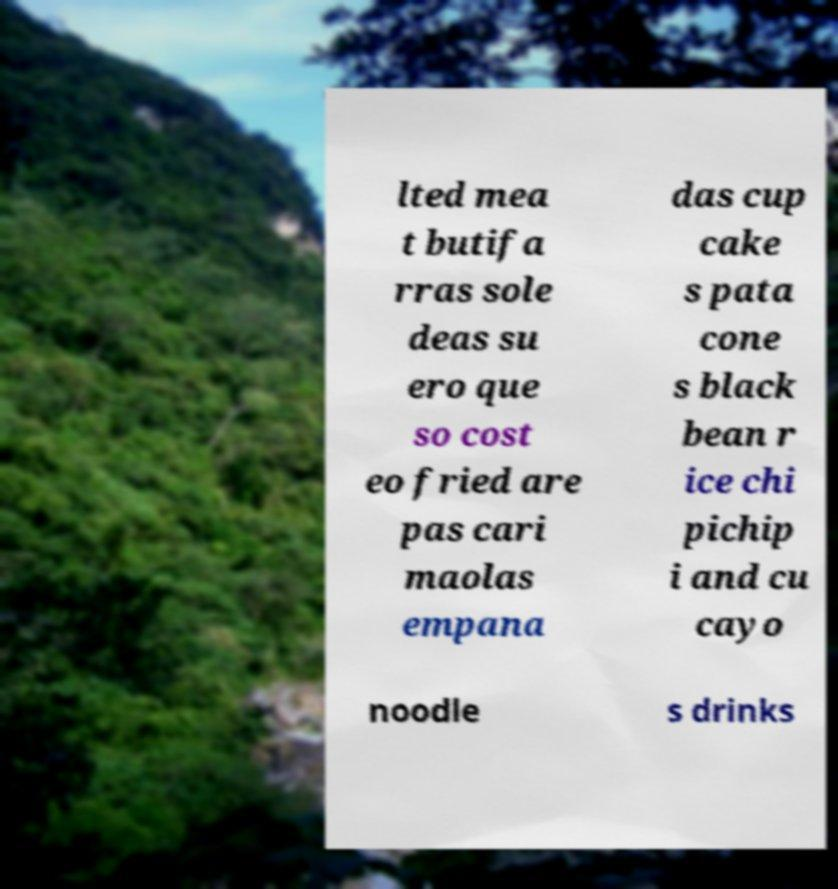I need the written content from this picture converted into text. Can you do that? lted mea t butifa rras sole deas su ero que so cost eo fried are pas cari maolas empana das cup cake s pata cone s black bean r ice chi pichip i and cu cayo noodle s drinks 